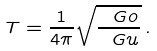Convert formula to latex. <formula><loc_0><loc_0><loc_500><loc_500>T = \frac { 1 } { 4 \pi } \sqrt { \frac { \ G o } { \ G u } } \, .</formula> 